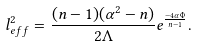<formula> <loc_0><loc_0><loc_500><loc_500>l _ { e f f } ^ { 2 } = \frac { ( n - 1 ) ( \alpha ^ { 2 } - n ) } { 2 \Lambda } e ^ { \frac { - 4 \alpha \Phi } { n - 1 } } .</formula> 